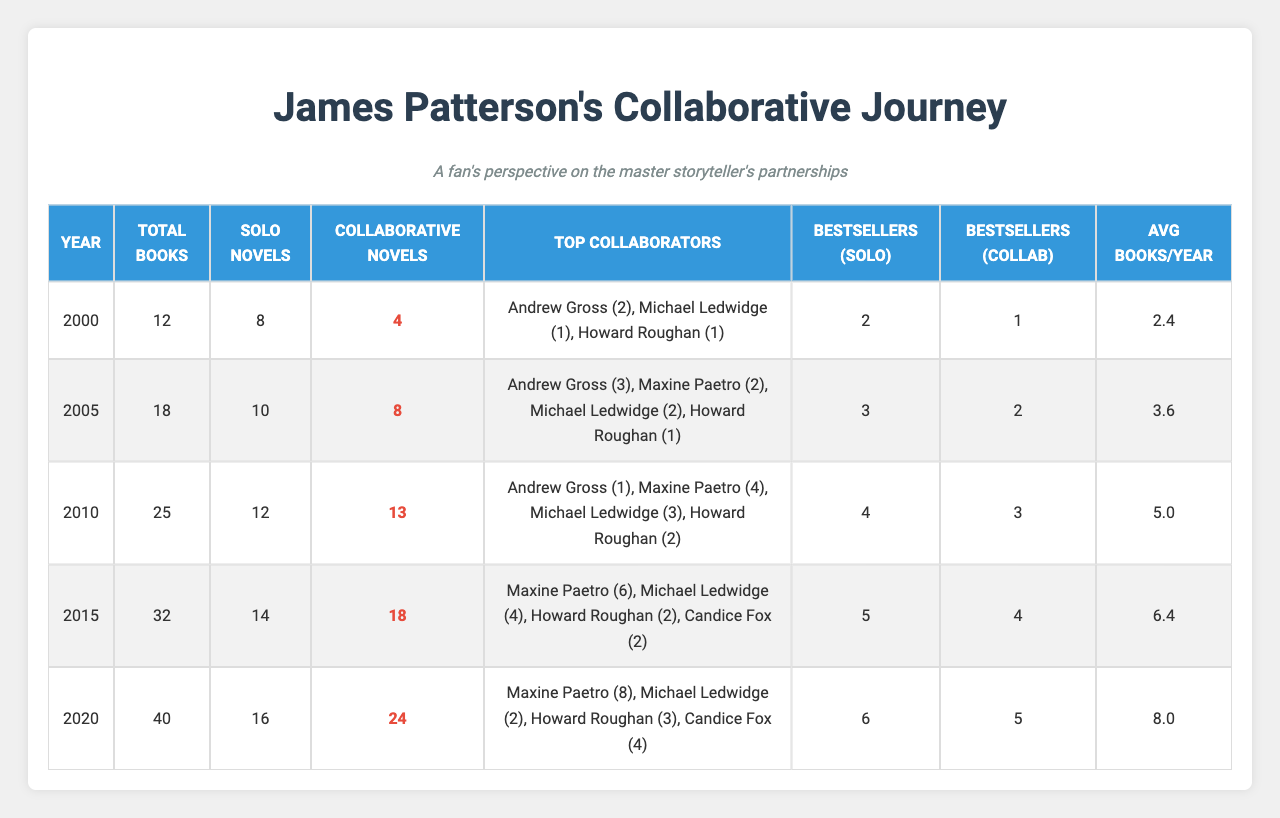What year had the highest number of collaborative novels published? Looking through the table, 2020 shows the highest number of collaborative novels at 24.
Answer: 2020 How many solo novels were published in 2015? The table indicates that 14 solo novels were published in 2015.
Answer: 14 In which genre did James Patterson publish the most collaborative novels in 2020? In 2020, he published 9 collaborative novels in the Crime Thriller genre, which is the highest among the genres listed.
Answer: Crime Thriller What is the total number of books published from 2000 to 2020? Adding the total books published each year gives us: 12 + 18 + 25 + 32 + 40 = 127.
Answer: 127 Did the number of bestsellers in collaborative novels increase every year since 2010? The number of bestsellers in collaborative novels increased from 3 in 2010 to 5 in 2020, so yes, it has consistently increased each year.
Answer: Yes What was the average number of books published per year from 2000 to 2020? Summing the average books per year gives (2.4 + 3.6 + 5.0 + 6.4 + 8.0) = 25.4 over 5 years, leading to an average of 25.4 / 5 = 5.08 books published per year.
Answer: 5.08 Which author collaborated with James Patterson the most frequently from 2000 to 2020? Examining the collaborations by author, Maxine Paetro collaborated a total of 20 times (0 + 2 + 4 + 6 + 8), which is the highest total among all listed.
Answer: Maxine Paetro What was the percentage increase in collaborative novels from 2015 to 2020? The increase in collaborative novels from 2015 (18) to 2020 (24) is 24 - 18 = 6. To find the percentage increase: (6 / 18) * 100 = 33.33%.
Answer: 33.33% How many collaborative novels were published in the Suspense genre across all years listed? The collaborative novels in the Suspense genre for each year are: 1 + 2 + 3 + 4 + 6 = 16 collaborative novels published in total.
Answer: 16 During which year did James Patterson publish the least total books? The lowest total books published were in 2000 with 12 books.
Answer: 2000 